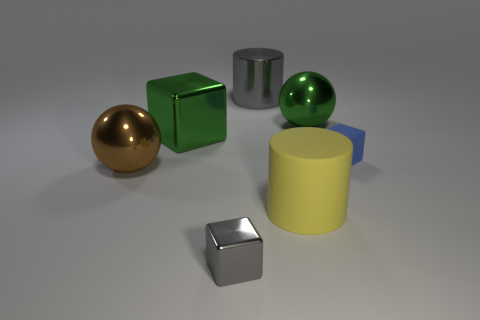Subtract all small blocks. How many blocks are left? 1 Add 2 big purple things. How many objects exist? 9 Subtract all green cubes. How many cubes are left? 2 Subtract all gray cubes. How many yellow cylinders are left? 1 Add 6 cylinders. How many cylinders are left? 8 Add 6 brown metallic balls. How many brown metallic balls exist? 7 Subtract 0 blue spheres. How many objects are left? 7 Subtract all cylinders. How many objects are left? 5 Subtract 1 cylinders. How many cylinders are left? 1 Subtract all gray spheres. Subtract all cyan cubes. How many spheres are left? 2 